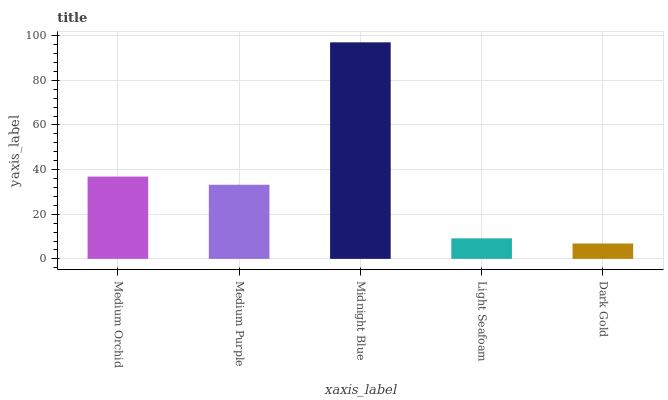Is Medium Purple the minimum?
Answer yes or no. No. Is Medium Purple the maximum?
Answer yes or no. No. Is Medium Orchid greater than Medium Purple?
Answer yes or no. Yes. Is Medium Purple less than Medium Orchid?
Answer yes or no. Yes. Is Medium Purple greater than Medium Orchid?
Answer yes or no. No. Is Medium Orchid less than Medium Purple?
Answer yes or no. No. Is Medium Purple the high median?
Answer yes or no. Yes. Is Medium Purple the low median?
Answer yes or no. Yes. Is Light Seafoam the high median?
Answer yes or no. No. Is Medium Orchid the low median?
Answer yes or no. No. 